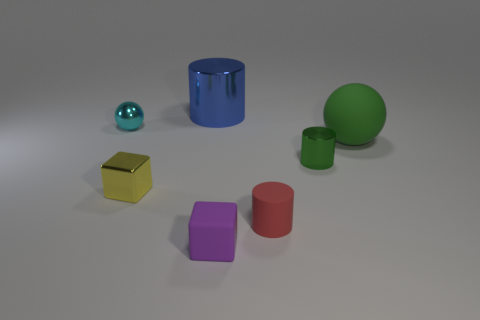Add 3 red matte cylinders. How many objects exist? 10 Subtract all blocks. How many objects are left? 5 Subtract all big yellow metallic balls. Subtract all big cylinders. How many objects are left? 6 Add 5 green rubber objects. How many green rubber objects are left? 6 Add 7 gray matte cylinders. How many gray matte cylinders exist? 7 Subtract 0 yellow balls. How many objects are left? 7 